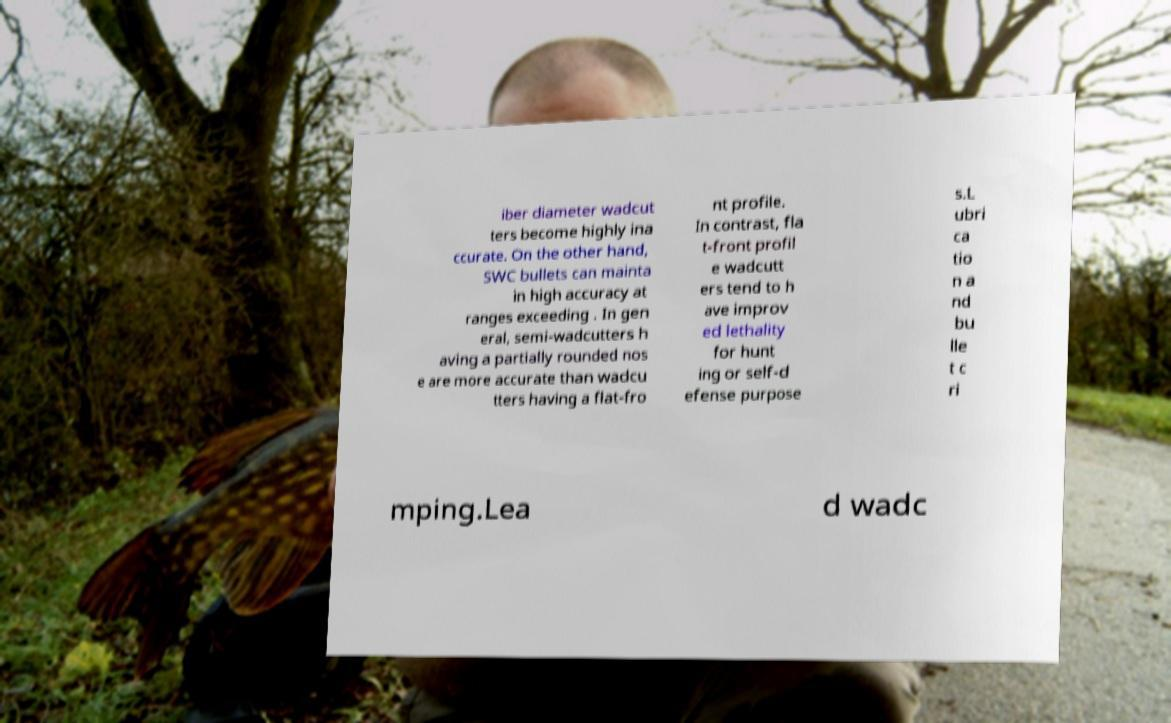What messages or text are displayed in this image? I need them in a readable, typed format. iber diameter wadcut ters become highly ina ccurate. On the other hand, SWC bullets can mainta in high accuracy at ranges exceeding . In gen eral, semi-wadcutters h aving a partially rounded nos e are more accurate than wadcu tters having a flat-fro nt profile. In contrast, fla t-front profil e wadcutt ers tend to h ave improv ed lethality for hunt ing or self-d efense purpose s.L ubri ca tio n a nd bu lle t c ri mping.Lea d wadc 